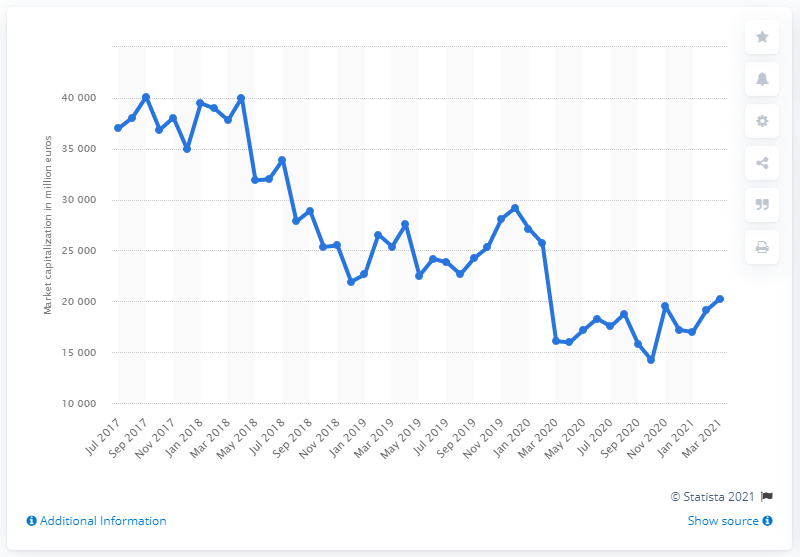Outline some significant characteristics in this image. The market capitalization of UniCredit in March 2021 was 20,273.44. 